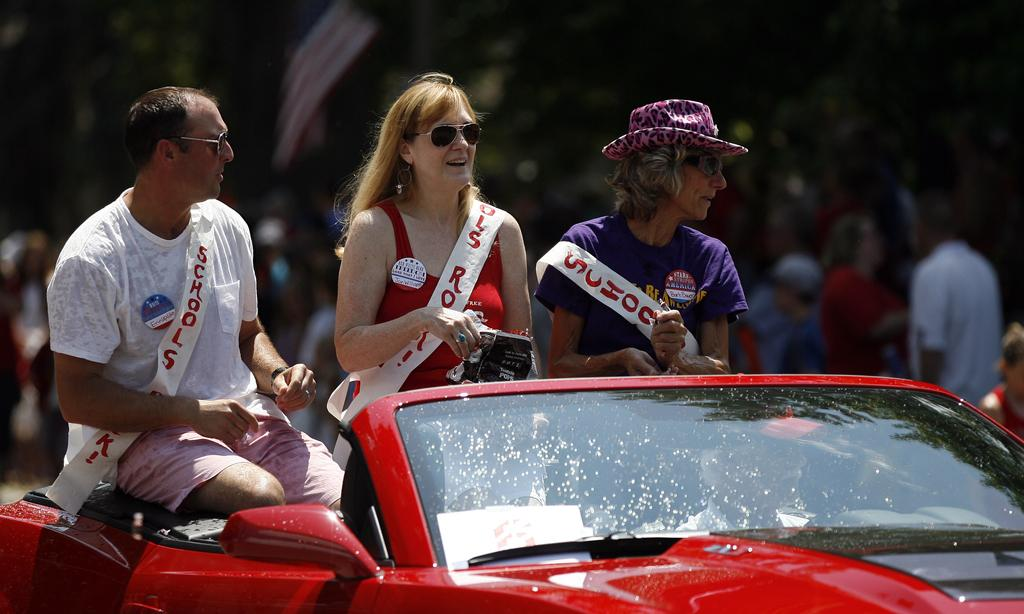What are the people in the image doing? The persons in the image are standing on a vehicle. Can you describe the attire of one of the women in the image? One woman is wearing a hat and goggles. What is the color of the vehicle in the image? The vehicle is red in color. Can you tell me how many crushed cars are visible in the image? There are no crushed cars visible in the image. What type of blood is visible on the woman's goggles in the image? There is no blood visible on the woman's goggles or anywhere else in the image. 